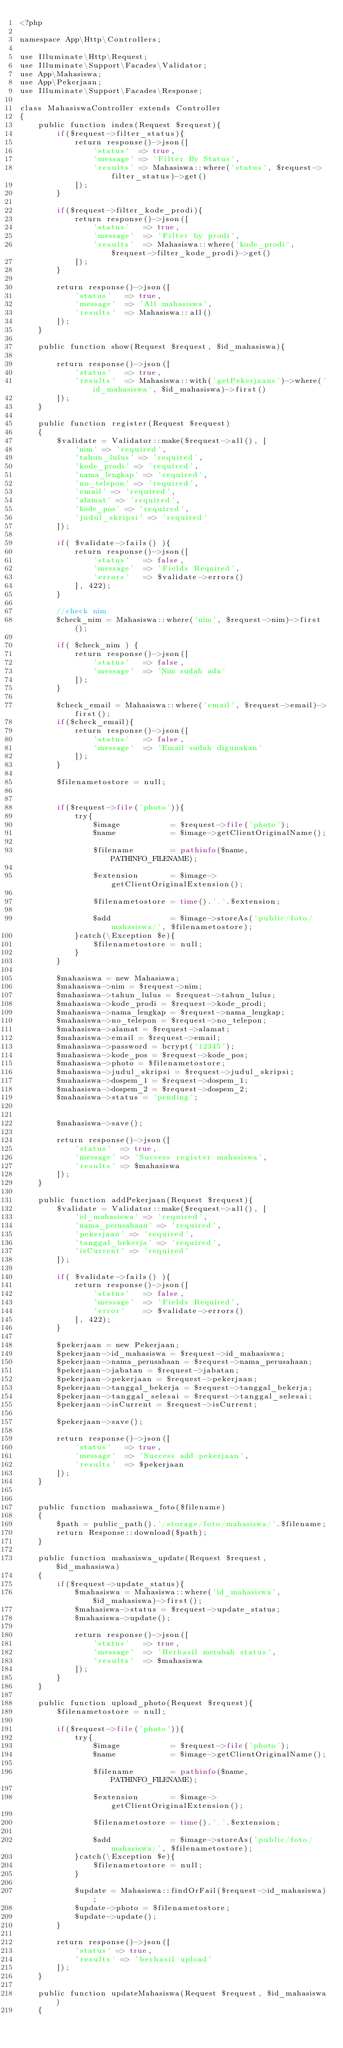<code> <loc_0><loc_0><loc_500><loc_500><_PHP_><?php

namespace App\Http\Controllers;

use Illuminate\Http\Request;
use Illuminate\Support\Facades\Validator;
use App\Mahasiswa;
use App\Pekerjaan;
use Illuminate\Support\Facades\Response;

class MahasiswaController extends Controller
{
    public function index(Request $request){
        if($request->filter_status){
            return response()->json([
                'status'  => true,
                'message' => 'Filter By Status',
                'results' => Mahasiswa::where('status', $request->filter_status)->get()
            ]);
        }

        if($request->filter_kode_prodi){
            return response()->json([
                'status'   => true,
                'message'  => 'Filter by prodi',
                'results'  => Mahasiswa::where('kode_prodi', $request->filter_kode_prodi)->get()
            ]);
        }

        return response()->json([
            'status'   => true,
            'message'  => 'All mahasiswa',
            'results'  => Mahasiswa::all()
        ]);
    }

    public function show(Request $request, $id_mahasiswa){
        
        return response()->json([
            'status'   => true,
            'results'  => Mahasiswa::with('getPekerjaans')->where('id_mahasiswa', $id_mahasiswa)->first()
        ]);
    }

    public function register(Request $request)
    {
        $validate = Validator::make($request->all(), [
            'nim' => 'required',
            'tahun_lulus' => 'required',
            'kode_prodi' => 'required',
            'nama_lengkap' => 'required',
            'no_telepon' => 'required',
            'email' => 'required',
            'alamat' => 'required',
            'kode_pos' => 'required',
            'judul_skripsi' => 'required'
        ]);

        if( $validate->fails() ){
            return response()->json([
                'status'   => false,
                'message'  => 'Fields Required',
                'errors'   => $validate->errors()
            ], 422);
        }

        //check nim
        $check_nim = Mahasiswa::where('nim', $request->nim)->first();

        if( $check_nim ) {
            return response()->json([
                'status'   => false,
                'message'  => 'Nim sudah ada'
            ]);
        }

        $check_email = Mahasiswa::where('email', $request->email)->first();
        if($check_email){
            return response()->json([
                'status'   => false,
                'message'  => 'Email sudah digunakan'
            ]);
        }

        $filenametostore = null;


        if($request->file('photo')){
            try{
                $image           = $request->file('photo');
                $name            = $image->getClientOriginalName();
    
                $filename        = pathinfo($name, PATHINFO_FILENAME);
    
                $extension       = $image->getClientOriginalExtension();
    
                $filenametostore = time().'.'.$extension;
    
                $add             = $image->storeAs('public/foto/mahasiswa/', $filenametostore);
            }catch(\Exception $e){
                $filenametostore = null;
            }
        }

        $mahasiswa = new Mahasiswa;
        $mahasiswa->nim = $request->nim;
        $mahasiswa->tahun_lulus = $request->tahun_lulus;
        $mahasiswa->kode_prodi = $request->kode_prodi;
        $mahasiswa->nama_lengkap = $request->nama_lengkap;
        $mahasiswa->no_telepon = $request->no_telepon;
        $mahasiswa->alamat = $request->alamat;
        $mahasiswa->email = $request->email;
        $mahasiswa->password = bcrypt('12345');
        $mahasiswa->kode_pos = $request->kode_pos;
        $mahasiswa->photo = $filenametostore;
        $mahasiswa->judul_skripsi = $request->judul_skripsi;
        $mahasiswa->dospem_1 = $request->dospem_1;
        $mahasiswa->dospem_2 = $request->dospem_2;
        $mahasiswa->status = 'pending';
        

        $mahasiswa->save();

        return response()->json([
            'status'  => true,
            'message' => 'Success register mahasiswa',
            'results' => $mahasiswa
        ]);
    }

    public function addPekerjaan(Request $request){
        $validate = Validator::make($request->all(), [
            'id_mahasiswa' => 'required',
            'nama_perusahaan' => 'required',
            'pekerjaan' => 'required',
            'tanggal_bekerja' => 'required',
            'isCurrent' => 'required'
        ]);

        if( $validate->fails() ){
            return response()->json([
                'status'   => false,
                'message'  => 'Fields Required',
                'error'    => $validate->errors()
            ], 422);
        }

        $pekerjaan = new Pekerjaan;
        $pekerjaan->id_mahasiswa = $request->id_mahasiswa;
        $pekerjaan->nama_perusahaan = $request->nama_perusahaan;
        $pekerjaan->jabatan = $request->jabatan;
        $pekerjaan->pekerjaan = $request->pekerjaan;
        $pekerjaan->tanggal_bekerja = $request->tanggal_bekerja;
        $pekerjaan->tanggal_selesai = $request->tanggal_selesai;
        $pekerjaan->isCurrent = $request->isCurrent;

        $pekerjaan->save();

        return response()->json([
            'status'   => true,
            'message'  => 'Success add pekerjaan',
            'results'  => $pekerjaan
        ]);
    }


    public function mahasiswa_foto($filename)
    {
        $path = public_path().'/storage/foto/mahasiswa/'.$filename;
        return Response::download($path);
    }

    public function mahasiswa_update(Request $request, $id_mahasiswa)
    {
        if($request->update_status){
            $mahasiswa = Mahasiswa::where('id_mahasiswa', $id_mahasiswa)->first();
            $mahasiswa->status = $request->update_status;
            $mahasiswa->update();

            return response()->json([
                'status'   => true,
                'message'  => 'Berhasil merubah status',
                'results'  => $mahasiswa
            ]);
        }
    }

    public function upload_photo(Request $request){
        $filenametostore = null;
        
        if($request->file('photo')){
            try{
                $image           = $request->file('photo');
                $name            = $image->getClientOriginalName();
    
                $filename        = pathinfo($name, PATHINFO_FILENAME);
    
                $extension       = $image->getClientOriginalExtension();
    
                $filenametostore = time().'.'.$extension;
    
                $add             = $image->storeAs('public/foto/mahasiswa/', $filenametostore);
            }catch(\Exception $e){
                $filenametostore = null;
            }

            $update = Mahasiswa::findOrFail($request->id_mahasiswa);
            $update->photo = $filenametostore;
            $update->update();
        }

        return response()->json([
            'status' => true,
            'results' => 'berhasil upload'
        ]);
    }

    public function updateMahasiswa(Request $request, $id_mahasiswa)
    {</code> 